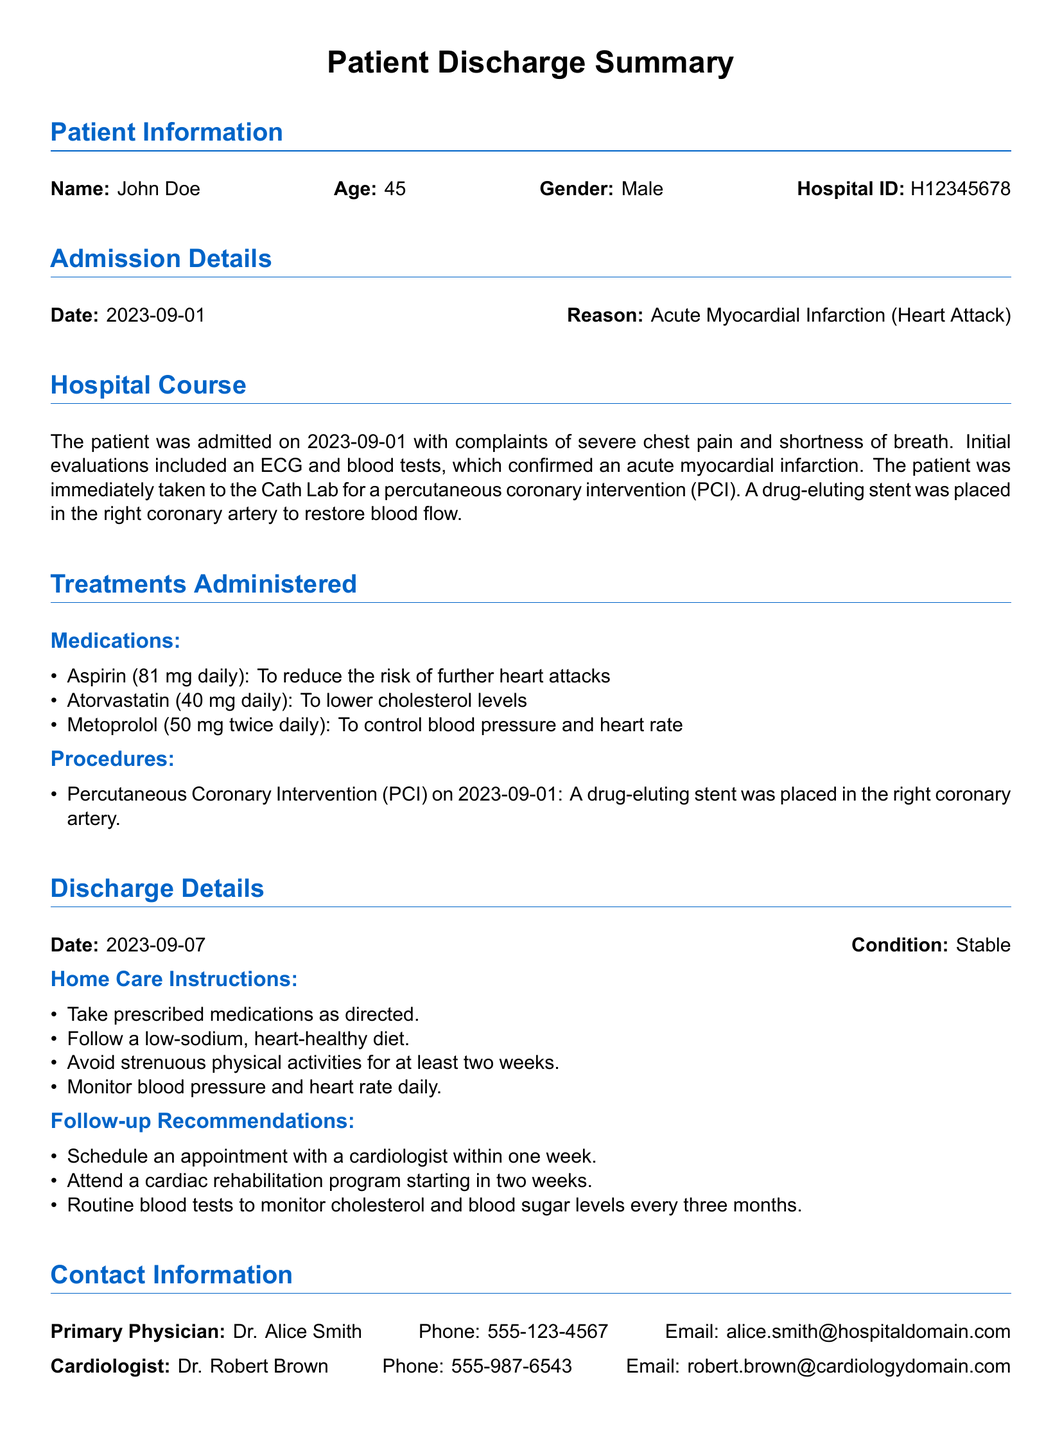What is the patient's name? The patient's name is provided in the Patient Information section.
Answer: John Doe What was the admission date? The admission date is specified in the Admission Details section.
Answer: 2023-09-01 What procedure did the patient undergo? The procedure is mentioned in the Treatments Administered section under Procedures.
Answer: Percutaneous Coronary Intervention (PCI) What medications is the patient prescribed? The medications are listed under Treatments Administered in the Medications subsection.
Answer: Aspirin, Atorvastatin, Metoprolol What is the discharge date? The discharge date is stated in the Discharge Details section.
Answer: 2023-09-07 What was the patient's discharge condition? The discharge condition is noted in the Discharge Details section.
Answer: Stable How long should the patient avoid strenuous physical activities? This instruction is included under Home Care Instructions.
Answer: At least two weeks When should the patient schedule a follow-up appointment with a cardiologist? This recommendation is part of the Follow-up Recommendations section.
Answer: Within one week Who is the primary physician? The primary physician's name is given in the Contact Information section.
Answer: Dr. Alice Smith 